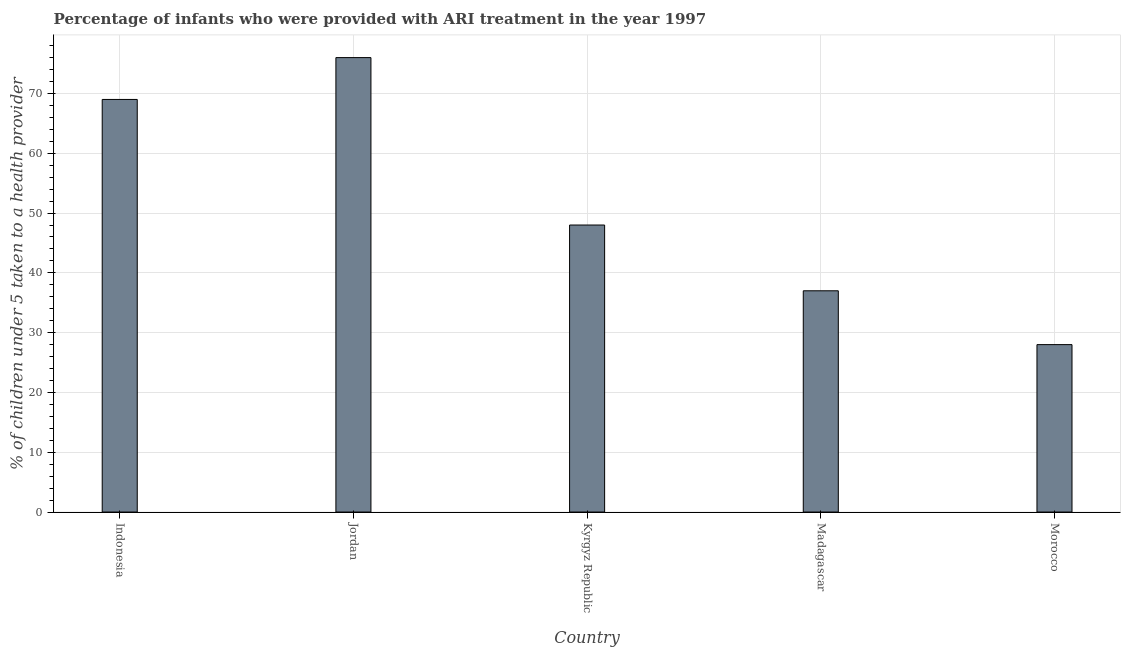What is the title of the graph?
Make the answer very short. Percentage of infants who were provided with ARI treatment in the year 1997. What is the label or title of the Y-axis?
Offer a terse response. % of children under 5 taken to a health provider. In which country was the percentage of children who were provided with ari treatment maximum?
Your response must be concise. Jordan. In which country was the percentage of children who were provided with ari treatment minimum?
Your answer should be compact. Morocco. What is the sum of the percentage of children who were provided with ari treatment?
Provide a succinct answer. 258. In how many countries, is the percentage of children who were provided with ari treatment greater than 72 %?
Your response must be concise. 1. What is the ratio of the percentage of children who were provided with ari treatment in Indonesia to that in Morocco?
Keep it short and to the point. 2.46. What is the difference between the highest and the second highest percentage of children who were provided with ari treatment?
Offer a terse response. 7. What is the difference between the highest and the lowest percentage of children who were provided with ari treatment?
Ensure brevity in your answer.  48. In how many countries, is the percentage of children who were provided with ari treatment greater than the average percentage of children who were provided with ari treatment taken over all countries?
Ensure brevity in your answer.  2. How many bars are there?
Offer a terse response. 5. Are the values on the major ticks of Y-axis written in scientific E-notation?
Provide a succinct answer. No. What is the % of children under 5 taken to a health provider of Kyrgyz Republic?
Your answer should be very brief. 48. What is the difference between the % of children under 5 taken to a health provider in Indonesia and Kyrgyz Republic?
Give a very brief answer. 21. What is the difference between the % of children under 5 taken to a health provider in Jordan and Madagascar?
Provide a succinct answer. 39. What is the difference between the % of children under 5 taken to a health provider in Jordan and Morocco?
Provide a succinct answer. 48. What is the difference between the % of children under 5 taken to a health provider in Kyrgyz Republic and Morocco?
Make the answer very short. 20. What is the difference between the % of children under 5 taken to a health provider in Madagascar and Morocco?
Offer a terse response. 9. What is the ratio of the % of children under 5 taken to a health provider in Indonesia to that in Jordan?
Ensure brevity in your answer.  0.91. What is the ratio of the % of children under 5 taken to a health provider in Indonesia to that in Kyrgyz Republic?
Ensure brevity in your answer.  1.44. What is the ratio of the % of children under 5 taken to a health provider in Indonesia to that in Madagascar?
Offer a terse response. 1.86. What is the ratio of the % of children under 5 taken to a health provider in Indonesia to that in Morocco?
Offer a very short reply. 2.46. What is the ratio of the % of children under 5 taken to a health provider in Jordan to that in Kyrgyz Republic?
Offer a very short reply. 1.58. What is the ratio of the % of children under 5 taken to a health provider in Jordan to that in Madagascar?
Offer a very short reply. 2.05. What is the ratio of the % of children under 5 taken to a health provider in Jordan to that in Morocco?
Make the answer very short. 2.71. What is the ratio of the % of children under 5 taken to a health provider in Kyrgyz Republic to that in Madagascar?
Make the answer very short. 1.3. What is the ratio of the % of children under 5 taken to a health provider in Kyrgyz Republic to that in Morocco?
Provide a succinct answer. 1.71. What is the ratio of the % of children under 5 taken to a health provider in Madagascar to that in Morocco?
Your response must be concise. 1.32. 